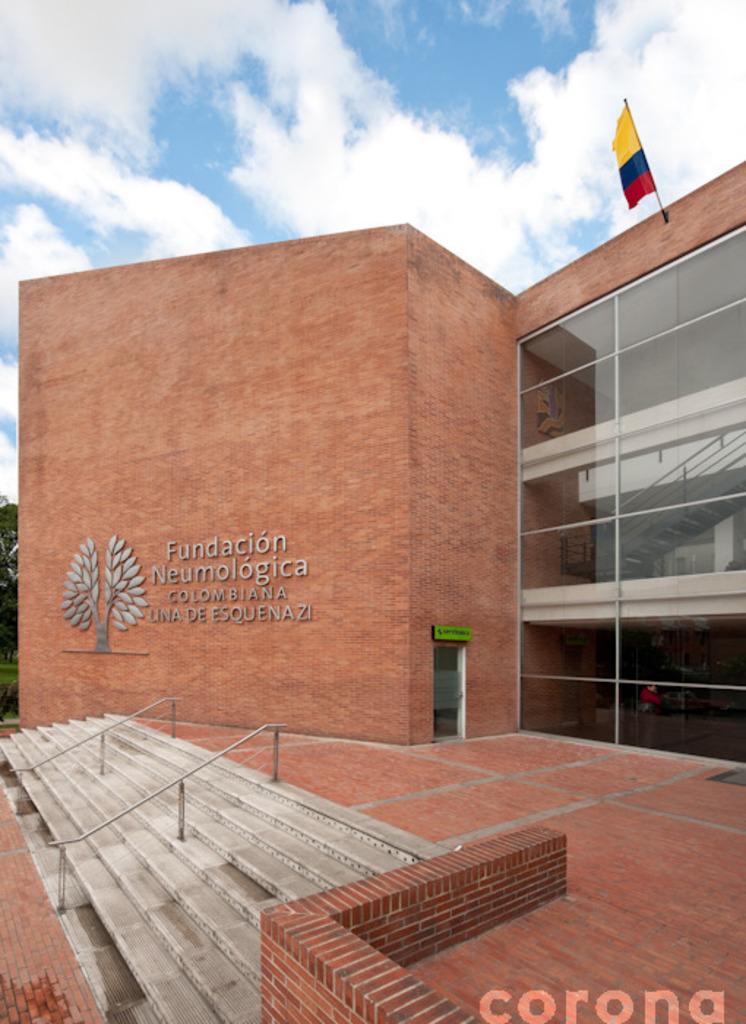How would you summarize this image in a sentence or two? In this picture I can see the building. On the right I can see the glass partition and flag. On the left I can see the trees and stairs. At the top I can see the sky and clouds. In the bottom right corner there is a watermark. 